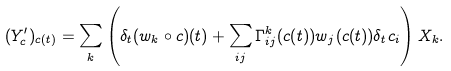Convert formula to latex. <formula><loc_0><loc_0><loc_500><loc_500>( Y _ { c } ^ { \prime } ) _ { c ( t ) } = \sum _ { k } \left ( \delta _ { t } ( w _ { k } \circ c ) ( t ) + \sum _ { i j } \Gamma ^ { k } _ { i j } ( c ( t ) ) w _ { j } ( c ( t ) ) \delta _ { t } c _ { i } \right ) X _ { k } .</formula> 